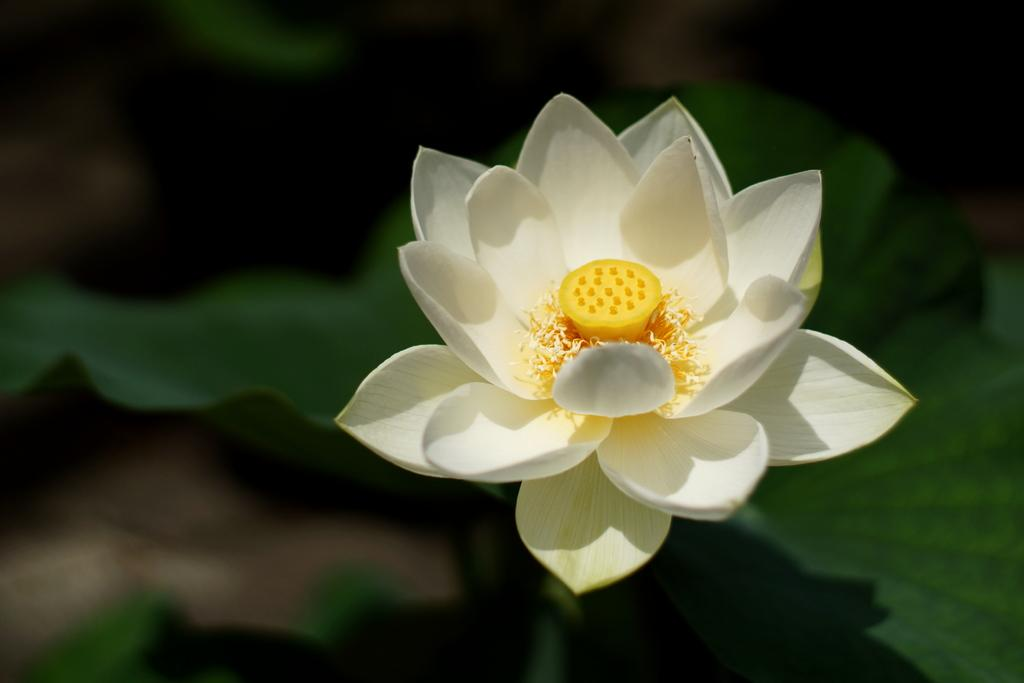What type of flower is in the image? There is a white color flower in the image. Where is the flower located in the image? The flower is located in the middle of the image. What type of alarm is present in the image? There is no alarm present in the image; it only features a white color flower. How many credits can be seen in the image? There are no credits visible in the image, as it only contains a white color flower. 